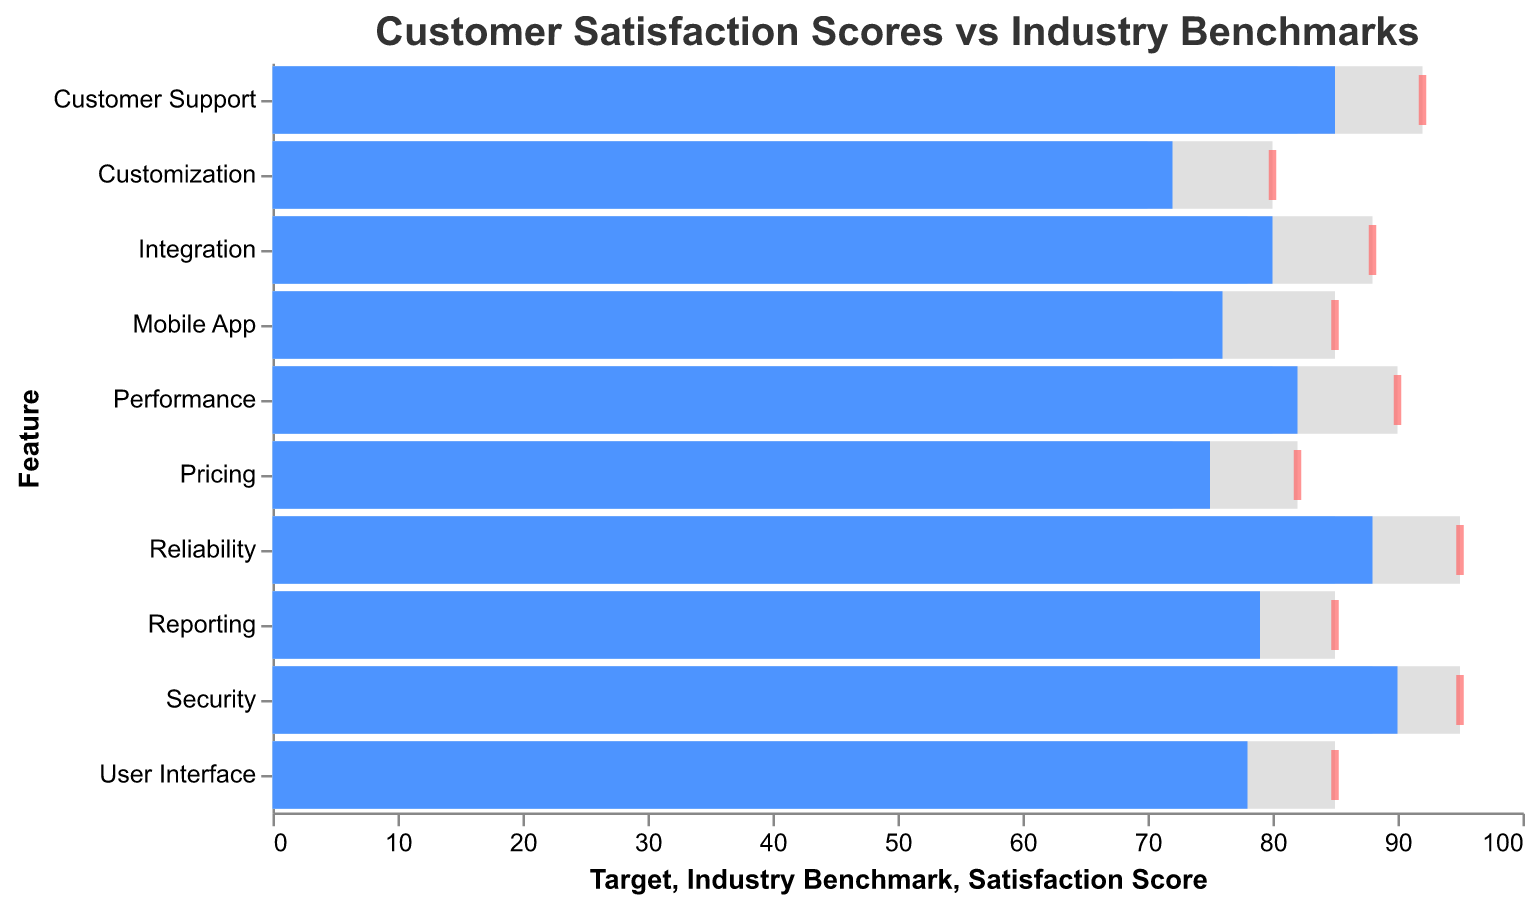What is the satisfaction score for the User Interface feature? The satisfaction score for the User Interface feature can be directly seen from the Satisfaction Score bar corresponding to the User Interface entry.
Answer: 78 Which feature has the highest satisfaction score, and what is that score? Examine the Satisfaction Score bars and identify the tallest one. The Security feature has the highest bar, indicating it has the highest satisfaction score, which is 90.
Answer: Security, 90 What is the difference between the satisfaction score and the industry benchmark for the Performance feature? Find the bars corresponding to the Performance feature. The Satisfaction Score is 82 and the Industry Benchmark is 80. Subtract the Industry Benchmark from the Satisfaction Score: 82 - 80.
Answer: 2 How close is the Mobile App satisfaction score to its target? For the Mobile App, find the Satisfaction Score (76) and the Target (85). Subtract the Satisfaction Score from the Target: 85 - 76.
Answer: 9 Which feature has the lowest satisfaction score and what is that score? Compare the heights of all the Satisfaction Score bars. Customization has the shortest bar, indicating it has the lowest satisfaction score, which is 72.
Answer: Customization, 72 Which feature meets or exceeds its target satisfaction score? Compare the Satisfaction Score bars with the corresponding Target ticks. No bar reaches or exceeds its corresponding tick, so no feature meets or exceeds its target.
Answer: None How does the satisfaction score for Customer Support compare to its industry benchmark? Look at the Customer Support Satisfaction Score bar (85) and the Industry Benchmark bar (82). The Satisfaction Score is higher than the Industry Benchmark.
Answer: Higher What is the average satisfaction score across all features? Add up all the satisfaction scores (78 + 82 + 88 + 85 + 76 + 80 + 72 + 90 + 79 + 75) and divide by the number of features (10). (78 + 82 + 88 + 85 + 76 + 80 + 72 + 90 + 79 + 75) / 10 = 80.5.
Answer: 80.5 Is the satisfaction score for Security higher than the target value for Performance? Compare the Satisfaction Score for Security (90) with the Target for Performance (90). Both values are the same, so the satisfaction score for Security is equal to the target value for Performance.
Answer: Equal What is the total of all industry benchmarks? Add up all industry benchmark values (75 + 80 + 85 + 82 + 72 + 78 + 70 + 88 + 75 + 72). (75 + 80 + 85 + 82 + 72 + 78 + 70 + 88 + 75 + 72) = 777.
Answer: 777 